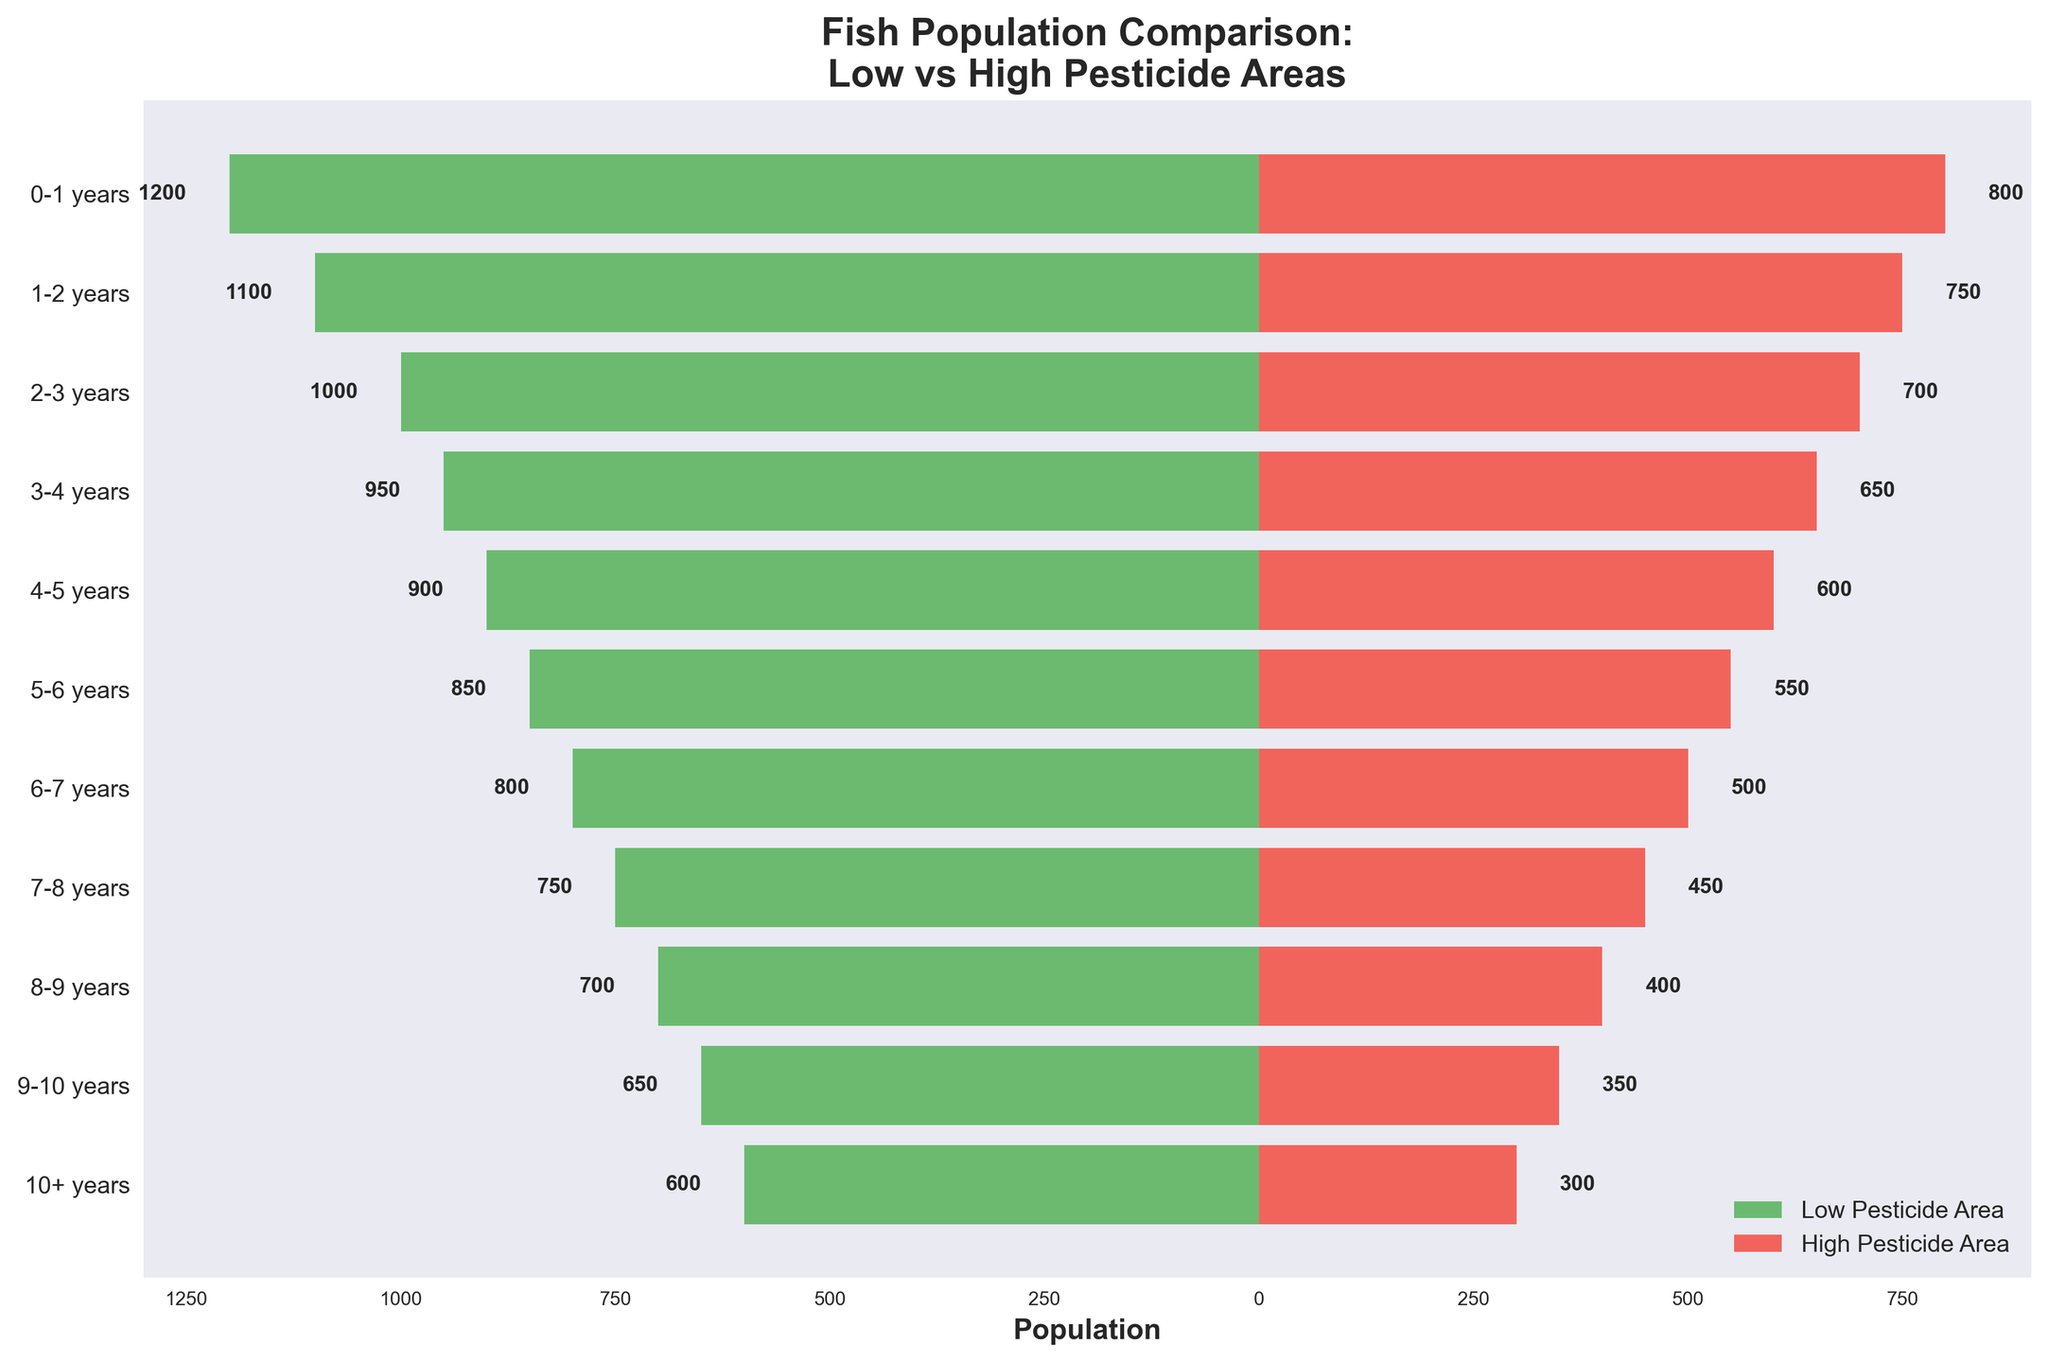How many fish aged 0-1 years are in the Low Pesticide Area? The bar on the left for the 0-1 years age group shows a length corresponding to 1200 fish.
Answer: 1200 Which age group has the highest number of fish in the Low Pesticide Area? By observing the lengths of the green bars, the 0-1 years group has the longest bar, representing the highest population of 1200.
Answer: 0-1 years What is the difference in the number of fish aged 3-4 years between the Low and High Pesticide Areas? The population for the 3-4 years group is 950 in the Low Pesticide Area and 650 in the High Pesticide Area. The difference is 950 - 650.
Answer: 300 What is the title of the figure? The title is displayed at the top of the figure.
Answer: Fish Population Comparison: Low vs High Pesticide Areas What percentage of the total population of the Low Pesticide Area are fish aged 1-2 years? Sum the populations of all age groups in the Low Pesticide Area: 1200+1100+1000+950+900+850+800+750+700+650+600 = 9500. The 1-2 years group has 1100 fish. The percentage is (1100 / 9500) * 100.
Answer: 11.58% Which age group has the smallest population in the High Pesticide Area? By examining the lengths of the red bars, the 10+ years group has the shortest bar, representing the smallest population of 300.
Answer: 10+ years What is the combined population of fish aged 2-3 years in both areas? The populations are 1000 in the Low Pesticide Area and 700 in the High Pesticide Area. The combined population is 1000 + 700.
Answer: 1700 Is the number of fish aged 0-1 years greater in the Low Pesticide Area or the High Pesticide Area? By comparing the lengths of the corresponding bars, the 0-1 years age group has 1200 fish in the Low Pesticide Area and 800 fish in the High Pesticide Area.
Answer: Low Pesticide Area What is the range of fish populations in the Low Pesticide Area? The maximum population is in the 0-1 years age group (1200), and the minimum population is in the 10+ years age group (600). The range is 1200 - 600.
Answer: 600 How does the population of fish aged 5-6 years in the High Pesticide Area compare to that in the Low Pesticide Area? The bar for the 5-6 years age group shows 550 fish in the High Pesticide Area and 850 fish in the Low Pesticide Area. The population in the High Pesticide Area is less.
Answer: Less 